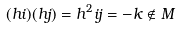<formula> <loc_0><loc_0><loc_500><loc_500>( h i ) ( h j ) = h ^ { 2 } i j = - k \notin M</formula> 